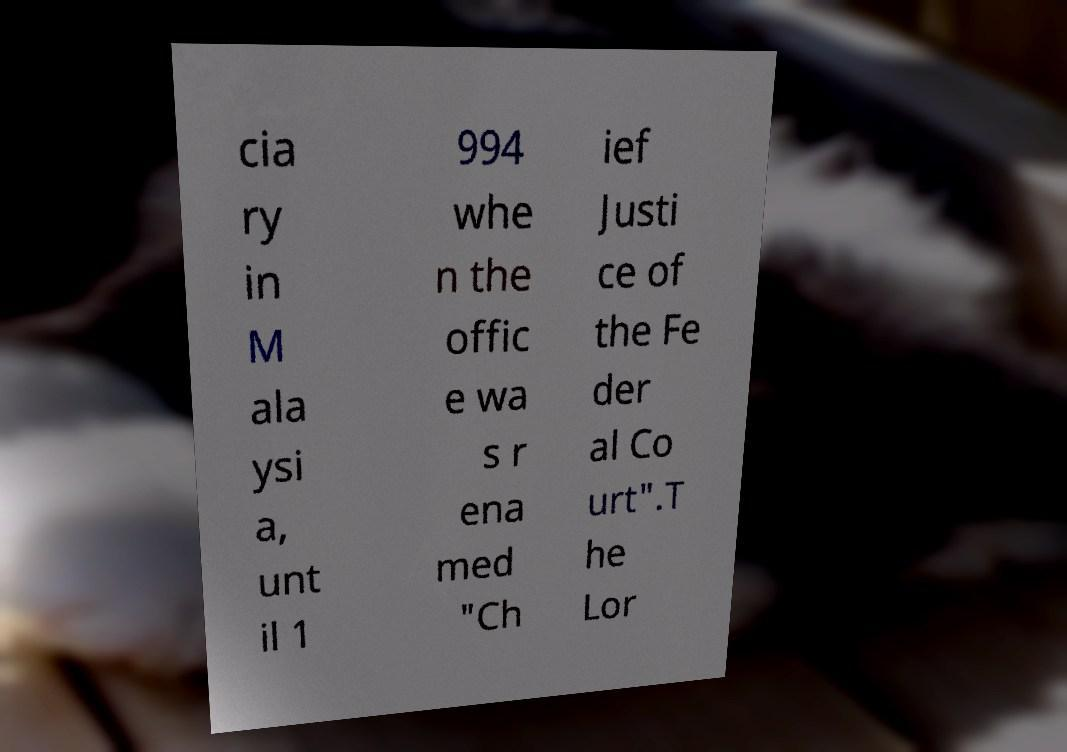Please read and relay the text visible in this image. What does it say? cia ry in M ala ysi a, unt il 1 994 whe n the offic e wa s r ena med "Ch ief Justi ce of the Fe der al Co urt".T he Lor 